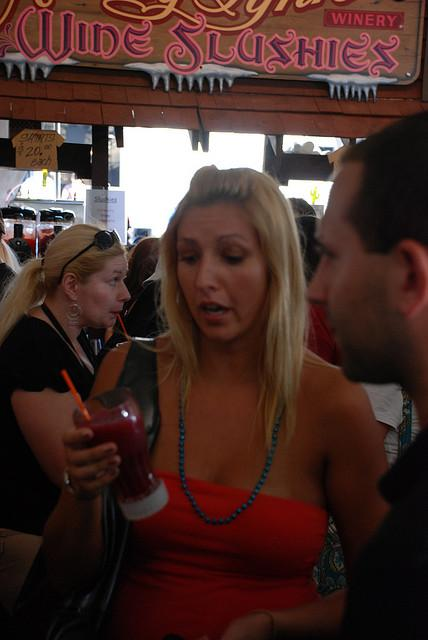Where are these people located? bar 